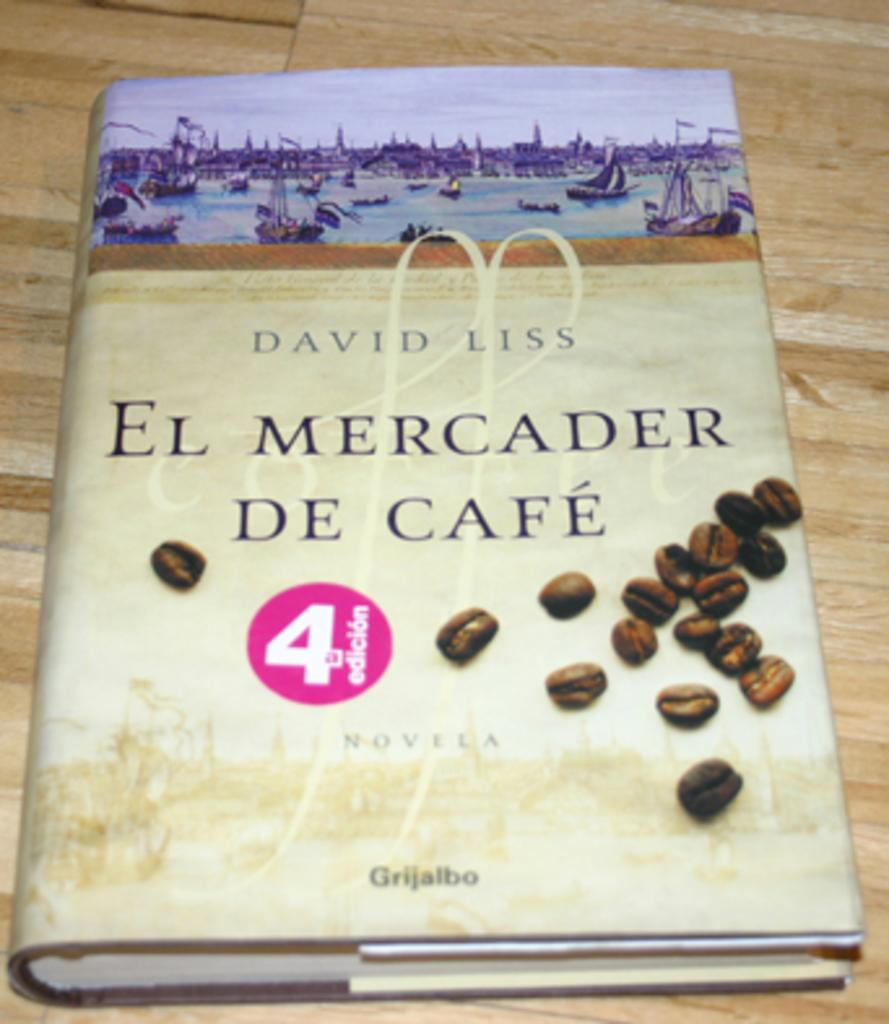<image>
Share a concise interpretation of the image provided. A book by David Liss called Eel Mercader de Cafe 